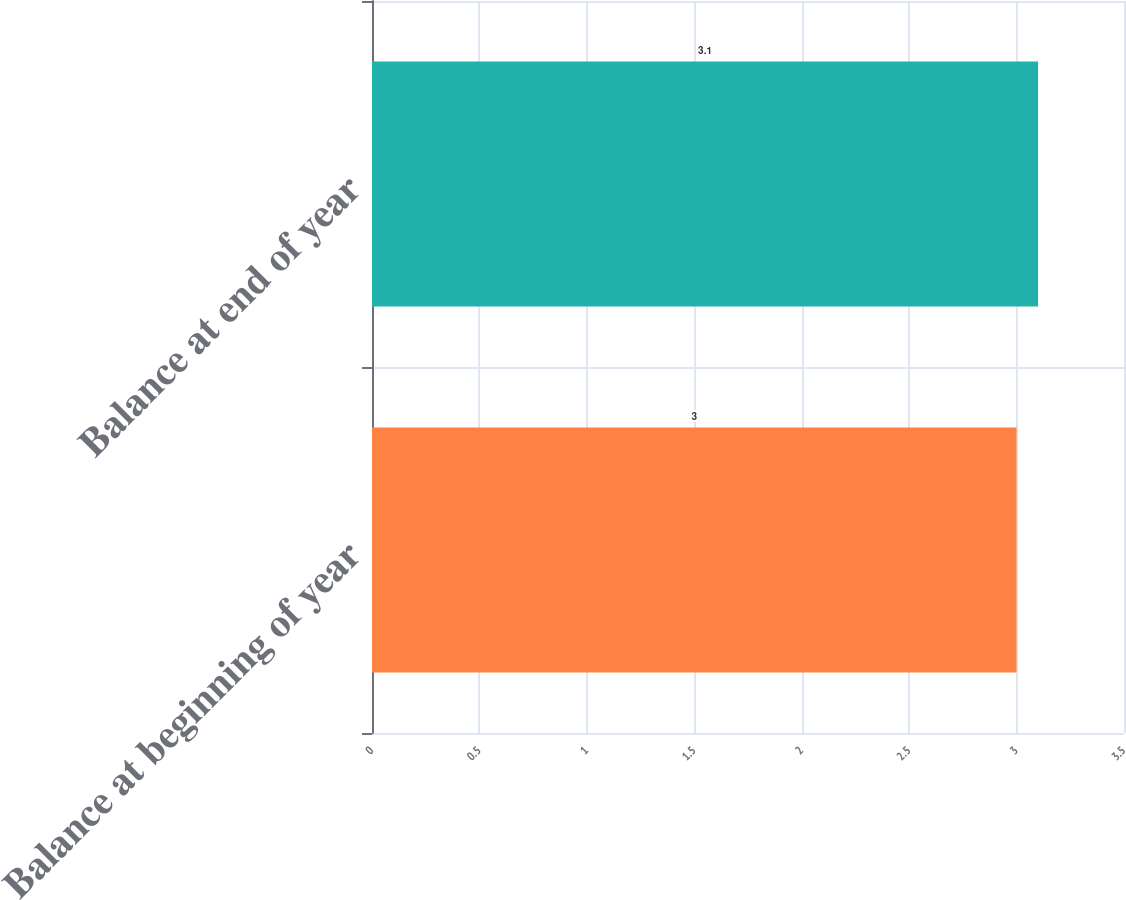Convert chart. <chart><loc_0><loc_0><loc_500><loc_500><bar_chart><fcel>Balance at beginning of year<fcel>Balance at end of year<nl><fcel>3<fcel>3.1<nl></chart> 